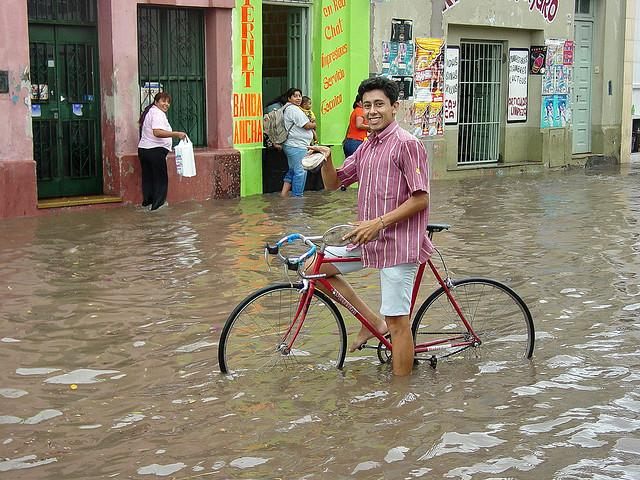Where is the man in? Please explain your reasoning. street. The man is biking through a street flood. 